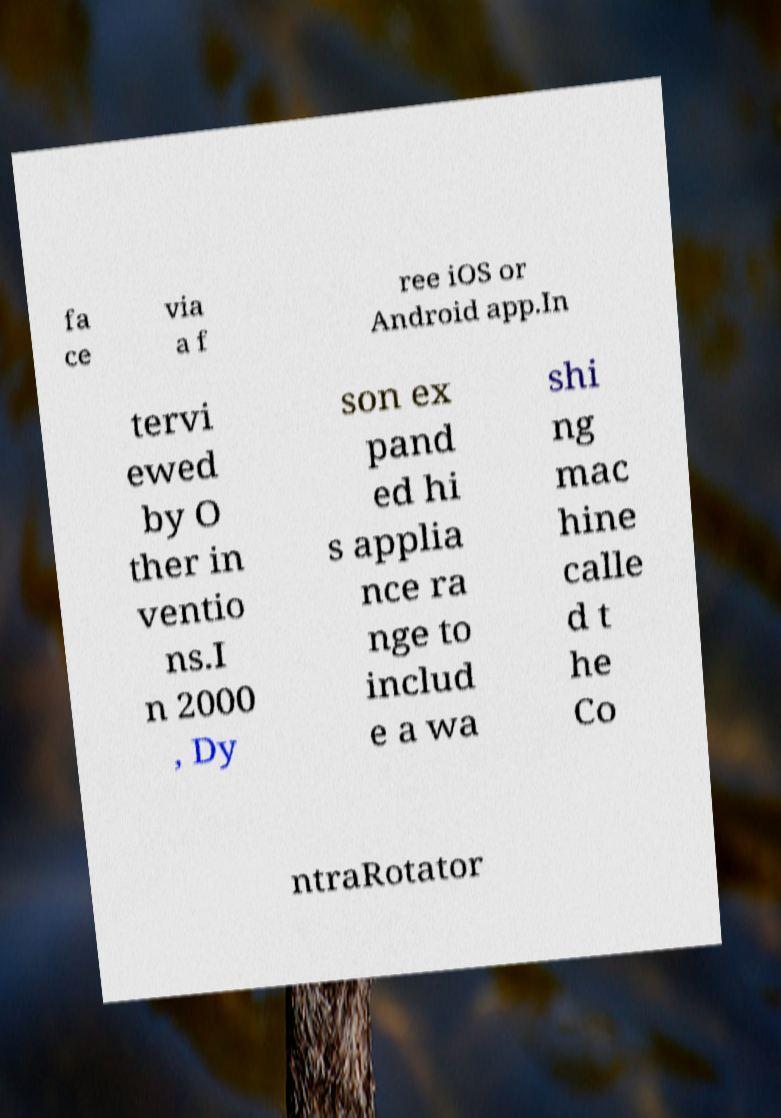I need the written content from this picture converted into text. Can you do that? fa ce via a f ree iOS or Android app.In tervi ewed by O ther in ventio ns.I n 2000 , Dy son ex pand ed hi s applia nce ra nge to includ e a wa shi ng mac hine calle d t he Co ntraRotator 